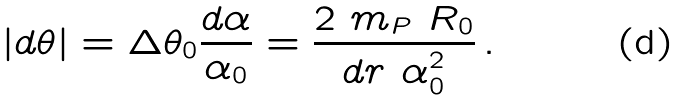Convert formula to latex. <formula><loc_0><loc_0><loc_500><loc_500>| d \theta | = \Delta \theta _ { 0 } \frac { d \alpha } { \alpha _ { 0 } } = \frac { 2 \ m _ { P } \ R _ { 0 } } { d r \ \alpha _ { 0 } ^ { 2 } } \, .</formula> 